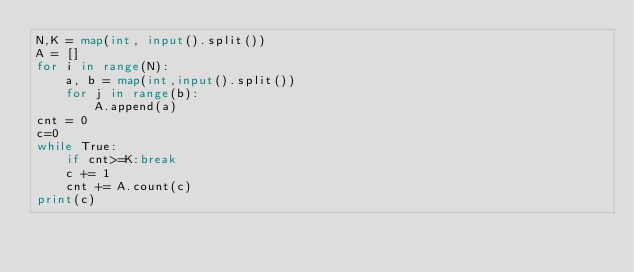<code> <loc_0><loc_0><loc_500><loc_500><_Python_>N,K = map(int, input().split())
A = []
for i in range(N):
    a, b = map(int,input().split())
    for j in range(b):
        A.append(a)
cnt = 0
c=0
while True:
    if cnt>=K:break
    c += 1
    cnt += A.count(c)
print(c)
</code> 